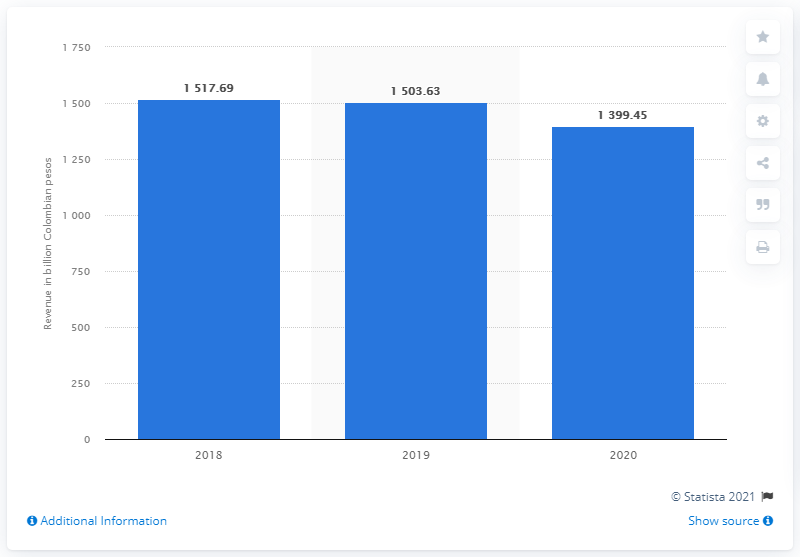Identify some key points in this picture. The revenue generated by ETB in the previous year was 1503.63. In 2020, Empresa de Telecomunicaciones de Bogot generated a revenue of 1,399.45. 